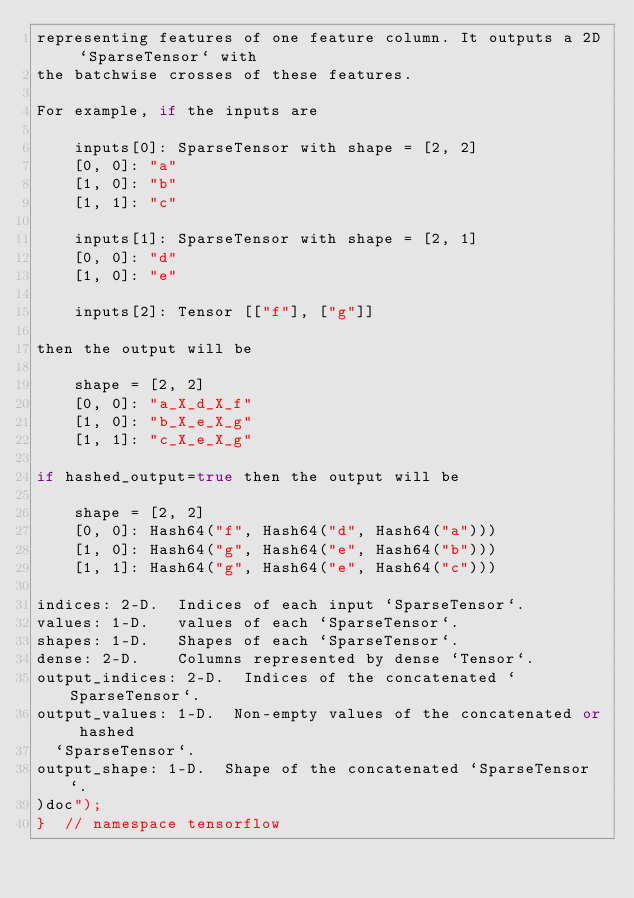<code> <loc_0><loc_0><loc_500><loc_500><_C++_>representing features of one feature column. It outputs a 2D `SparseTensor` with
the batchwise crosses of these features.

For example, if the inputs are

    inputs[0]: SparseTensor with shape = [2, 2]
    [0, 0]: "a"
    [1, 0]: "b"
    [1, 1]: "c"

    inputs[1]: SparseTensor with shape = [2, 1]
    [0, 0]: "d"
    [1, 0]: "e"

    inputs[2]: Tensor [["f"], ["g"]]

then the output will be

    shape = [2, 2]
    [0, 0]: "a_X_d_X_f"
    [1, 0]: "b_X_e_X_g"
    [1, 1]: "c_X_e_X_g"

if hashed_output=true then the output will be

    shape = [2, 2]
    [0, 0]: Hash64("f", Hash64("d", Hash64("a")))
    [1, 0]: Hash64("g", Hash64("e", Hash64("b")))
    [1, 1]: Hash64("g", Hash64("e", Hash64("c")))

indices: 2-D.  Indices of each input `SparseTensor`.
values: 1-D.   values of each `SparseTensor`.
shapes: 1-D.   Shapes of each `SparseTensor`.
dense: 2-D.    Columns represented by dense `Tensor`.
output_indices: 2-D.  Indices of the concatenated `SparseTensor`.
output_values: 1-D.  Non-empty values of the concatenated or hashed
  `SparseTensor`.
output_shape: 1-D.  Shape of the concatenated `SparseTensor`.
)doc");
}  // namespace tensorflow
</code> 